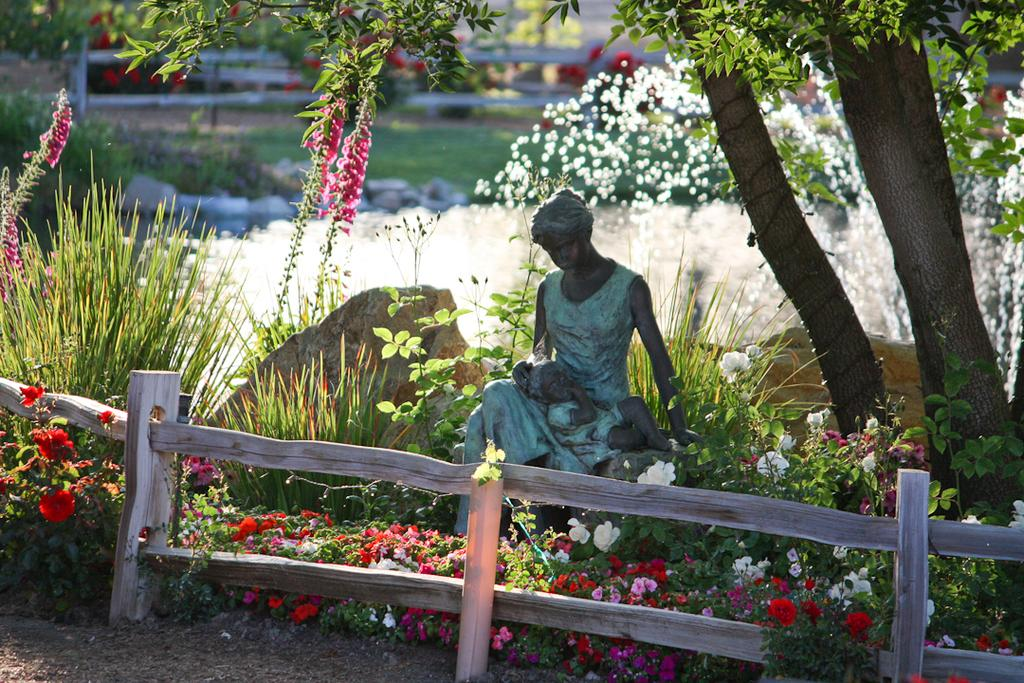What is the main subject in the center of the image? There is a statue in the center of the image. What can be seen at the bottom of the image? Fencing and flowers are visible at the bottom of the image. What is visible in the background of the image? Water, grass, trees, and fencing are visible in the background of the image. What type of can is being used to collect water from the bath in the image? There is no can or bath present in the image. 